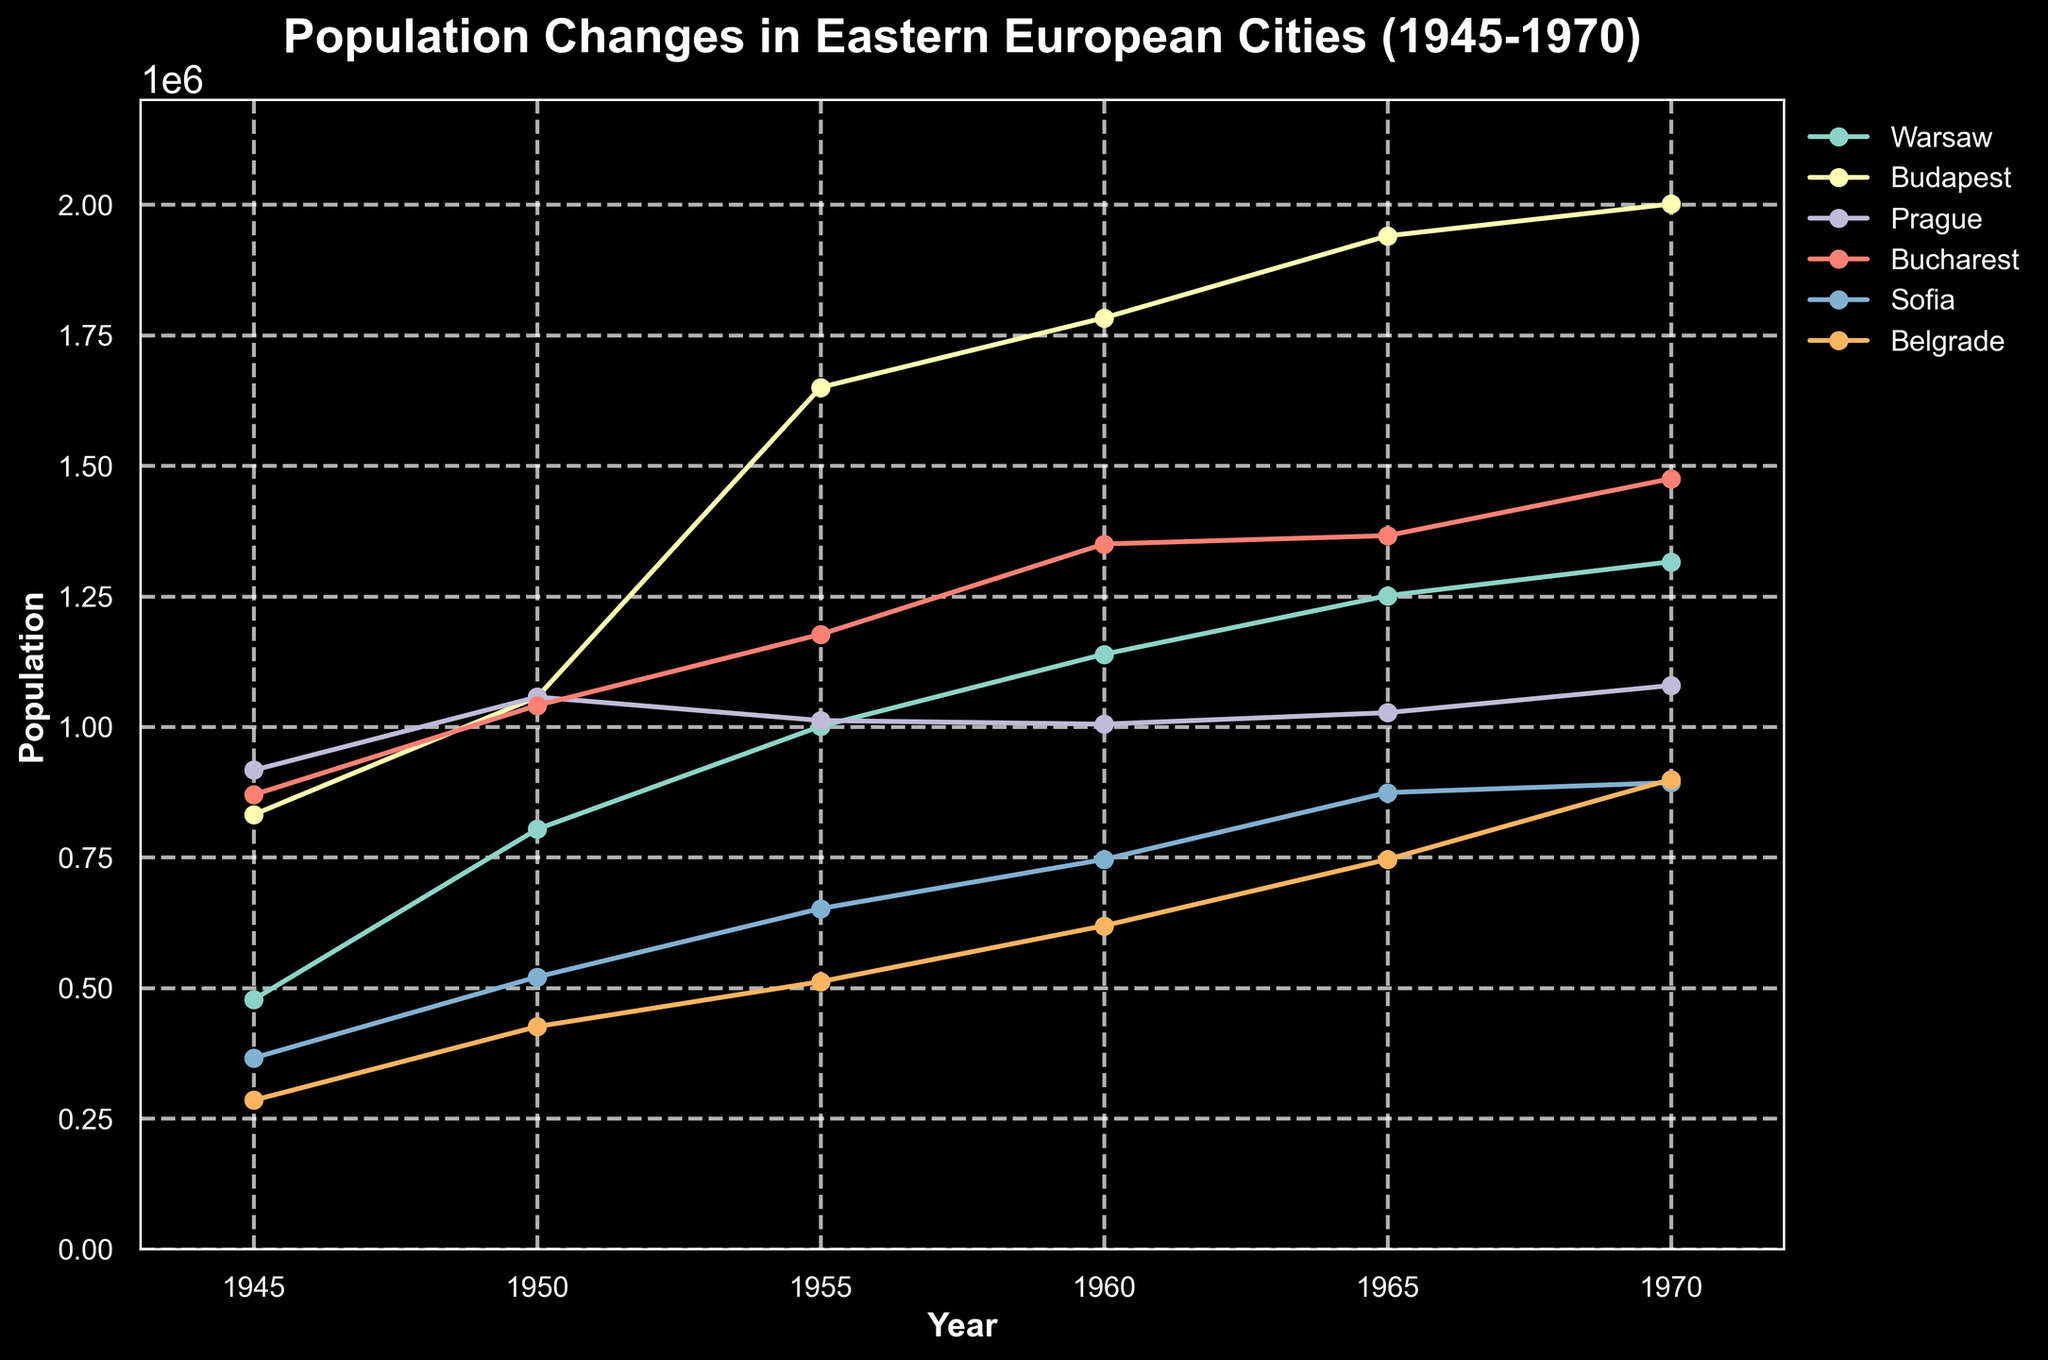Which city had the largest population increase from 1945 to 1970? To determine which city had the largest population increase, we calculate the difference between the population in 1970 and 1945 for each city: Warsaw (1316000 - 478000 = 838000), Budapest (2001000 - 832000 = 1169000), Prague (1079000 - 917000 = 162000), Bucharest (1475000 - 870000 = 605000), Sofia (893000 - 366000 = 527000), Belgrade (899000 - 285000 = 614000). By comparing these differences, Budapest has the largest increase.
Answer: Budapest By how much did the population of Belgrade grow between 1950 and 1960? To find the population growth of Belgrade between 1950 and 1960, subtract Belgrade's population in 1950 from its population in 1960: 619000 - 426000 = 193000.
Answer: 193000 Which city had the smallest population in 1945? Look at the population figures for 1945 and identify the lowest one. The populations in 1945 are: Warsaw (478000), Budapest (832000), Prague (917000), Bucharest (870000), Sofia (366000), Belgrade (285000). Belgrade has the smallest population.
Answer: Belgrade Did any city experience a population decrease in any interval between 1945 and 1970? By visually inspecting the plots for each city, look for any decreasing segments. The population for each city either remains the same or increases in all intervals; no city experienced a population decrease during the specified years.
Answer: No What was the total population of these six cities in 1970? Sum the population values for the six cities in 1970: Warsaw (1316000) + Budapest (2001000) + Prague (1079000) + Bucharest (1475000) + Sofia (893000) + Belgrade (899000). The total is 7663000.
Answer: 7663000 Which city had the slowest growth rate from 1945 to 1970? To determine the slowest growth rate, calculate the percentage increase for each city: Warsaw ((1316000-478000)/478000 ≈ 175%), Budapest ((2001000-832000)/832000 ≈ 141%), Prague ((1079000-917000)/917000 ≈ 18%), Bucharest ((1475000-870000)/870000 ≈ 70%), Sofia ((893000-366000)/366000 ≈ 144%), Belgrade ((899000-285000)/285000 ≈ 215%). Prague has the smallest percentage increase.
Answer: Prague In which year did Budapest surpass a population of 1.5 million? Examine the data for Budapest and identify the first year its population exceeds 1.5 million. This occurs in 1955 when the population reaches 1650000.
Answer: 1955 